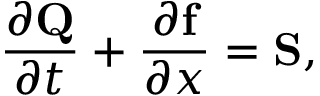Convert formula to latex. <formula><loc_0><loc_0><loc_500><loc_500>\frac { \partial Q } { \partial t } + \frac { \partial f } { \partial x } = S ,</formula> 